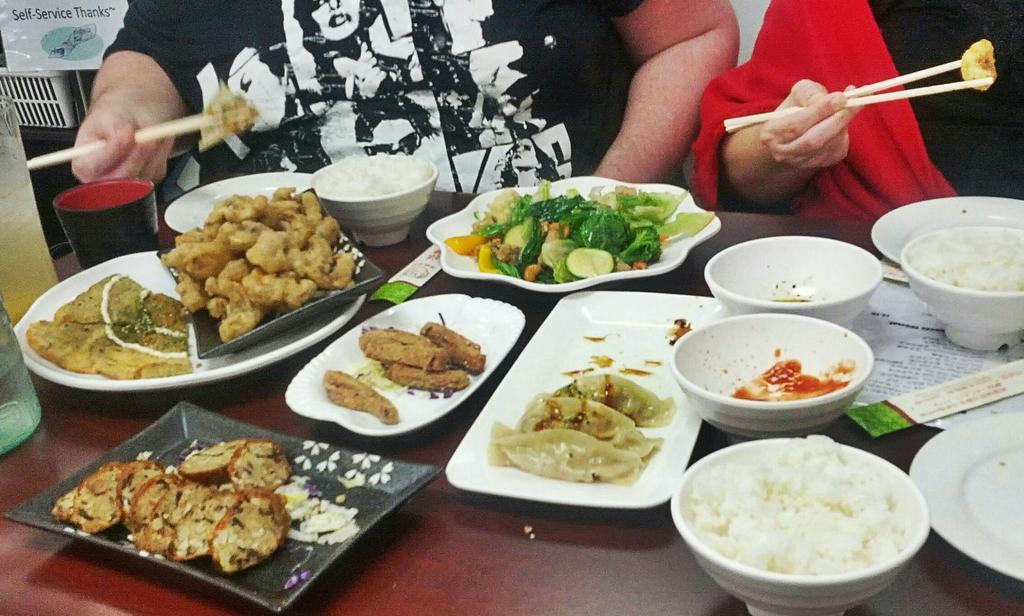How would you summarize this image in a sentence or two? There are two persons holding chopsticks with food item. There is a table. On the table there are food items on the plates, bowls and trays. Also there is a glass. 